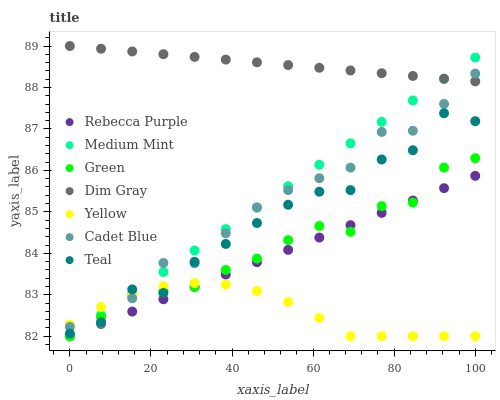Does Yellow have the minimum area under the curve?
Answer yes or no. Yes. Does Dim Gray have the maximum area under the curve?
Answer yes or no. Yes. Does Cadet Blue have the minimum area under the curve?
Answer yes or no. No. Does Cadet Blue have the maximum area under the curve?
Answer yes or no. No. Is Medium Mint the smoothest?
Answer yes or no. Yes. Is Teal the roughest?
Answer yes or no. Yes. Is Cadet Blue the smoothest?
Answer yes or no. No. Is Cadet Blue the roughest?
Answer yes or no. No. Does Medium Mint have the lowest value?
Answer yes or no. Yes. Does Cadet Blue have the lowest value?
Answer yes or no. No. Does Dim Gray have the highest value?
Answer yes or no. Yes. Does Cadet Blue have the highest value?
Answer yes or no. No. Is Rebecca Purple less than Teal?
Answer yes or no. Yes. Is Dim Gray greater than Green?
Answer yes or no. Yes. Does Cadet Blue intersect Yellow?
Answer yes or no. Yes. Is Cadet Blue less than Yellow?
Answer yes or no. No. Is Cadet Blue greater than Yellow?
Answer yes or no. No. Does Rebecca Purple intersect Teal?
Answer yes or no. No. 